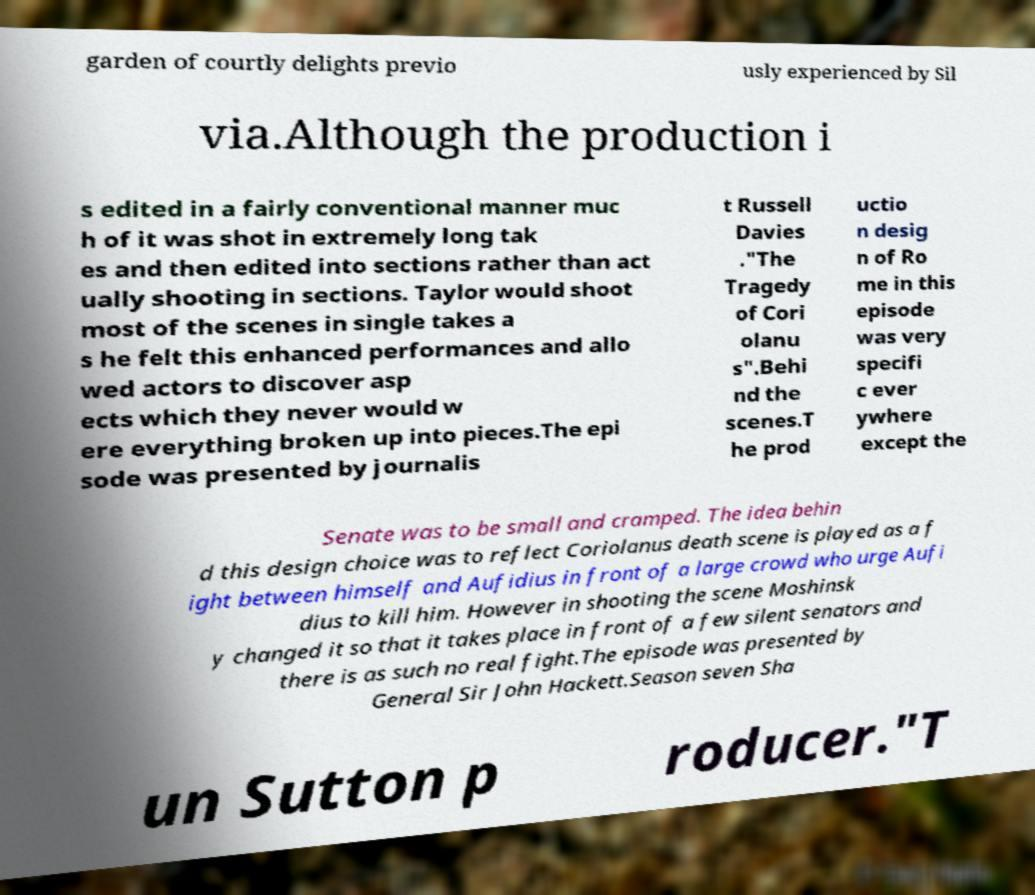Could you assist in decoding the text presented in this image and type it out clearly? garden of courtly delights previo usly experienced by Sil via.Although the production i s edited in a fairly conventional manner muc h of it was shot in extremely long tak es and then edited into sections rather than act ually shooting in sections. Taylor would shoot most of the scenes in single takes a s he felt this enhanced performances and allo wed actors to discover asp ects which they never would w ere everything broken up into pieces.The epi sode was presented by journalis t Russell Davies ."The Tragedy of Cori olanu s".Behi nd the scenes.T he prod uctio n desig n of Ro me in this episode was very specifi c ever ywhere except the Senate was to be small and cramped. The idea behin d this design choice was to reflect Coriolanus death scene is played as a f ight between himself and Aufidius in front of a large crowd who urge Aufi dius to kill him. However in shooting the scene Moshinsk y changed it so that it takes place in front of a few silent senators and there is as such no real fight.The episode was presented by General Sir John Hackett.Season seven Sha un Sutton p roducer."T 